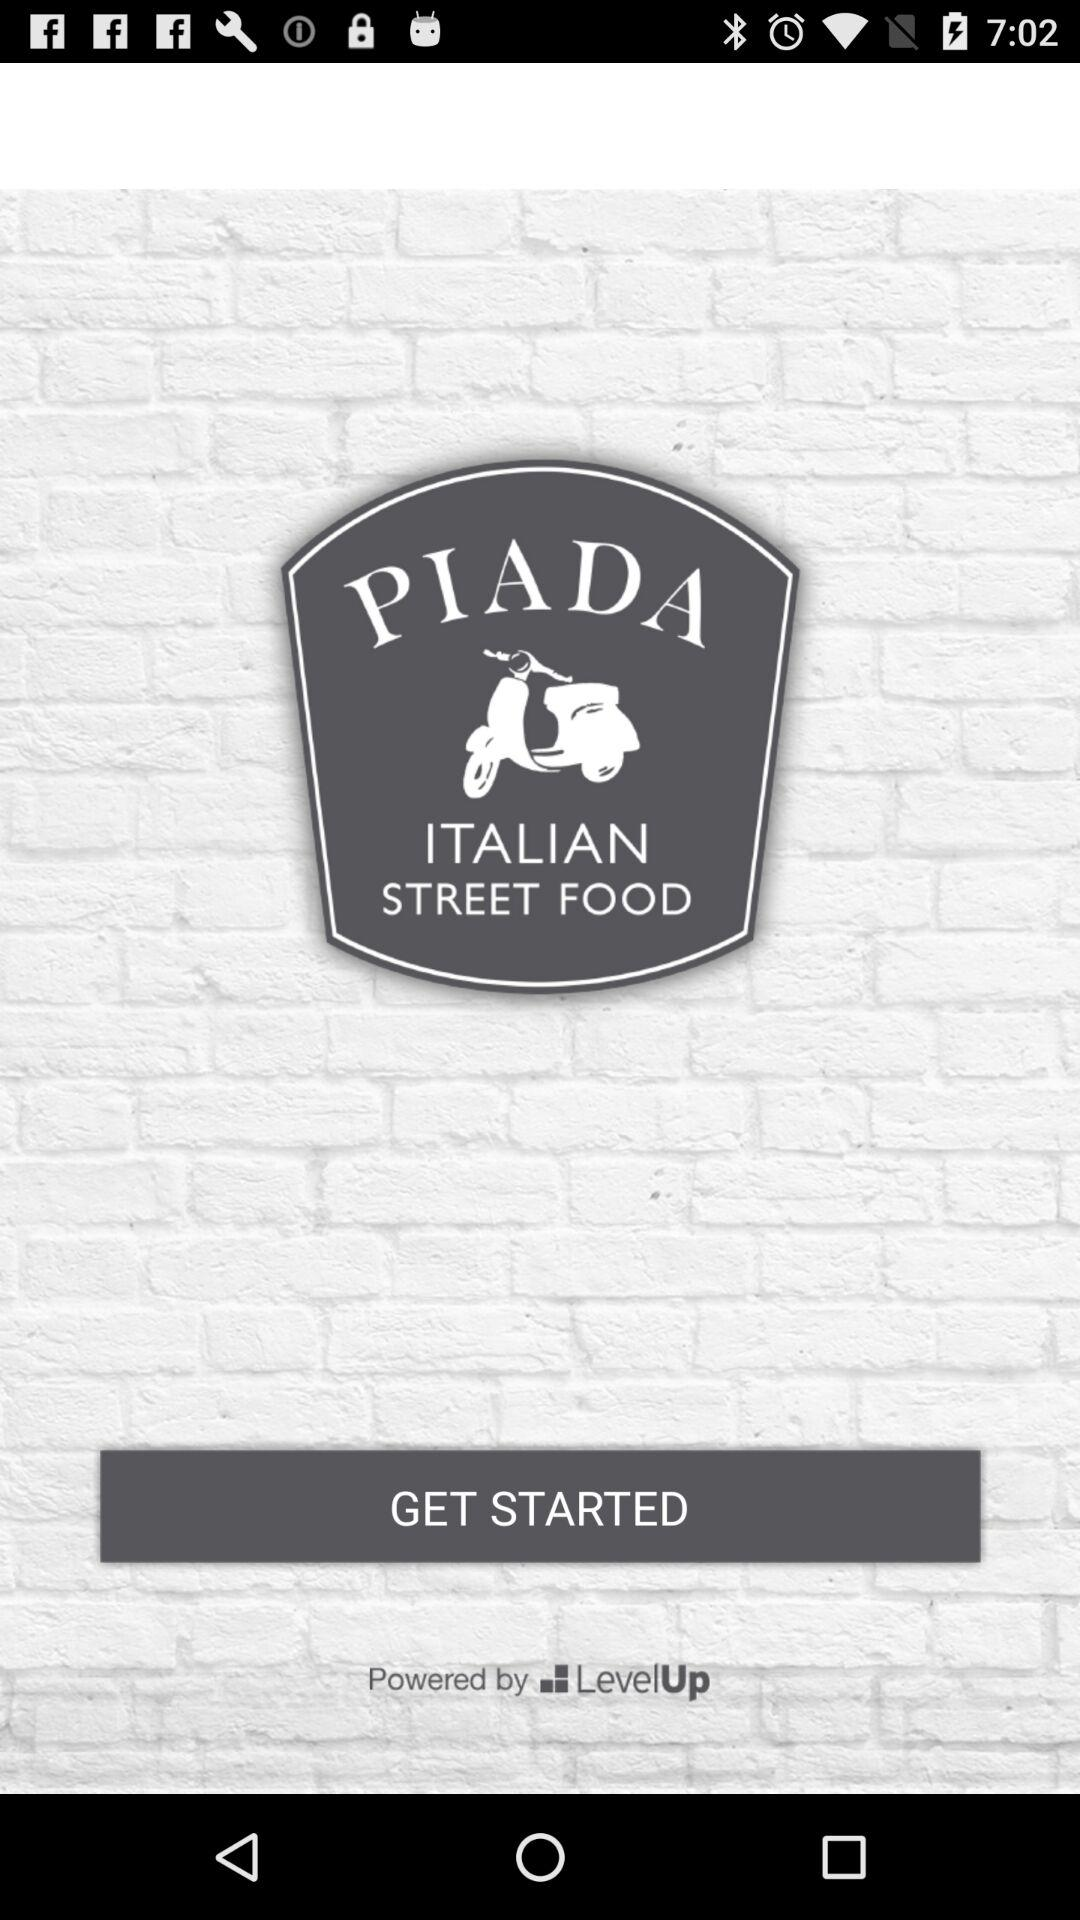By whom is "PIADA" powered? "PIADA" is powered by "LevelUp". 